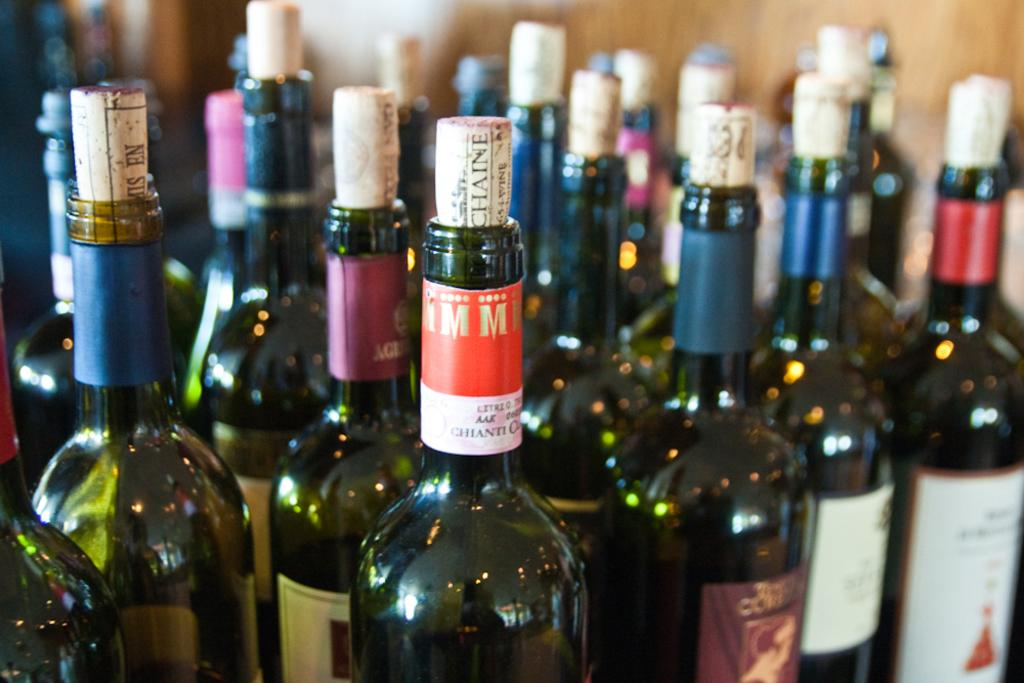<image>
Offer a succinct explanation of the picture presented. a bottle that has the letters mm on it 